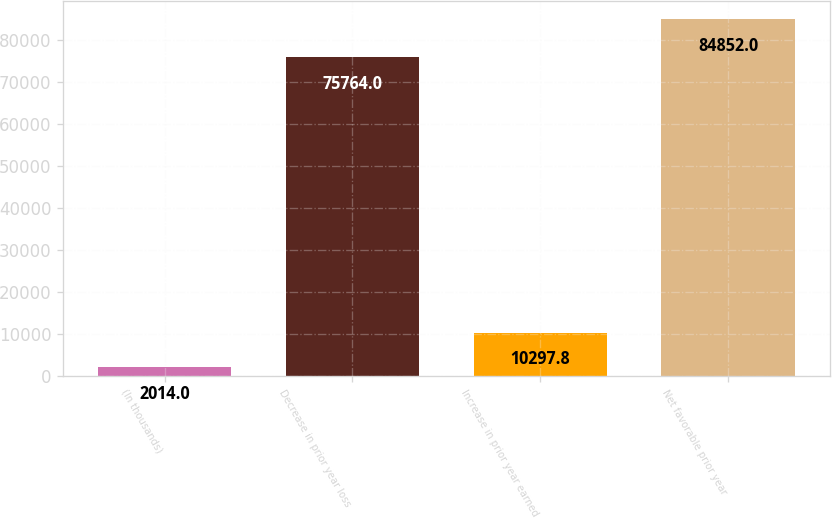<chart> <loc_0><loc_0><loc_500><loc_500><bar_chart><fcel>(In thousands)<fcel>Decrease in prior year loss<fcel>Increase in prior year earned<fcel>Net favorable prior year<nl><fcel>2014<fcel>75764<fcel>10297.8<fcel>84852<nl></chart> 